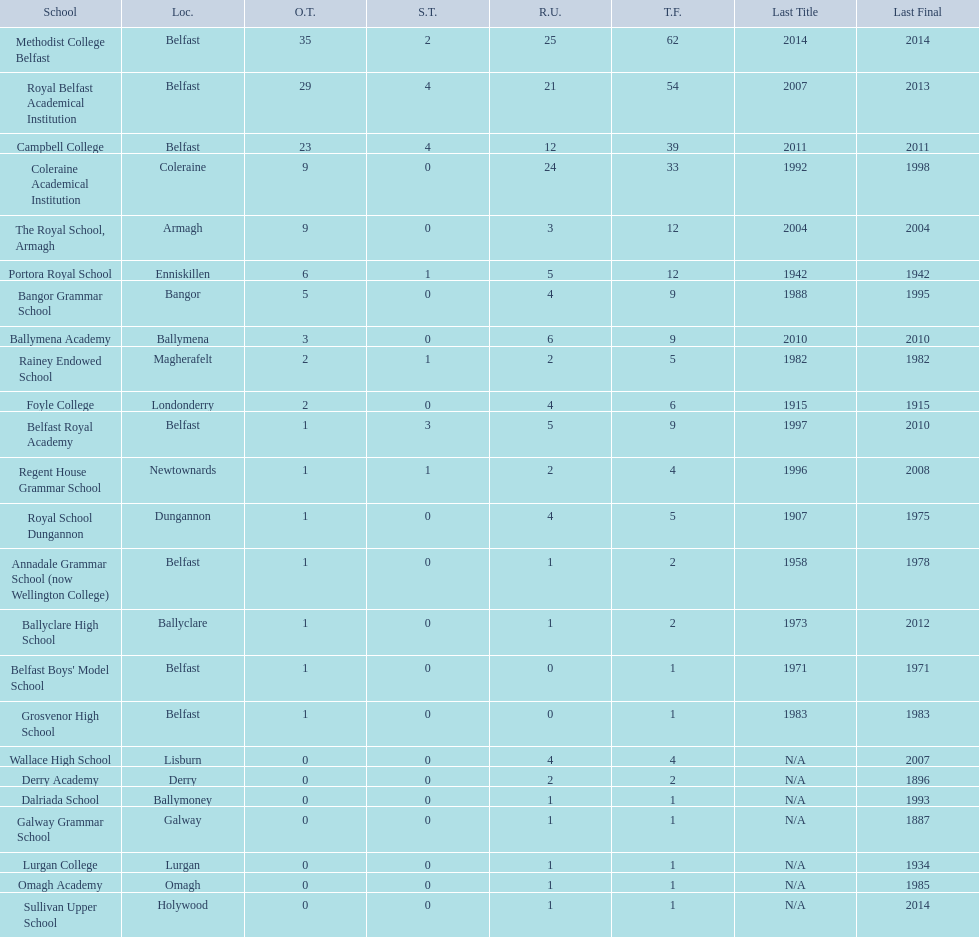How many outright titles does coleraine academical institution have? 9. What other school has this amount of outright titles The Royal School, Armagh. 